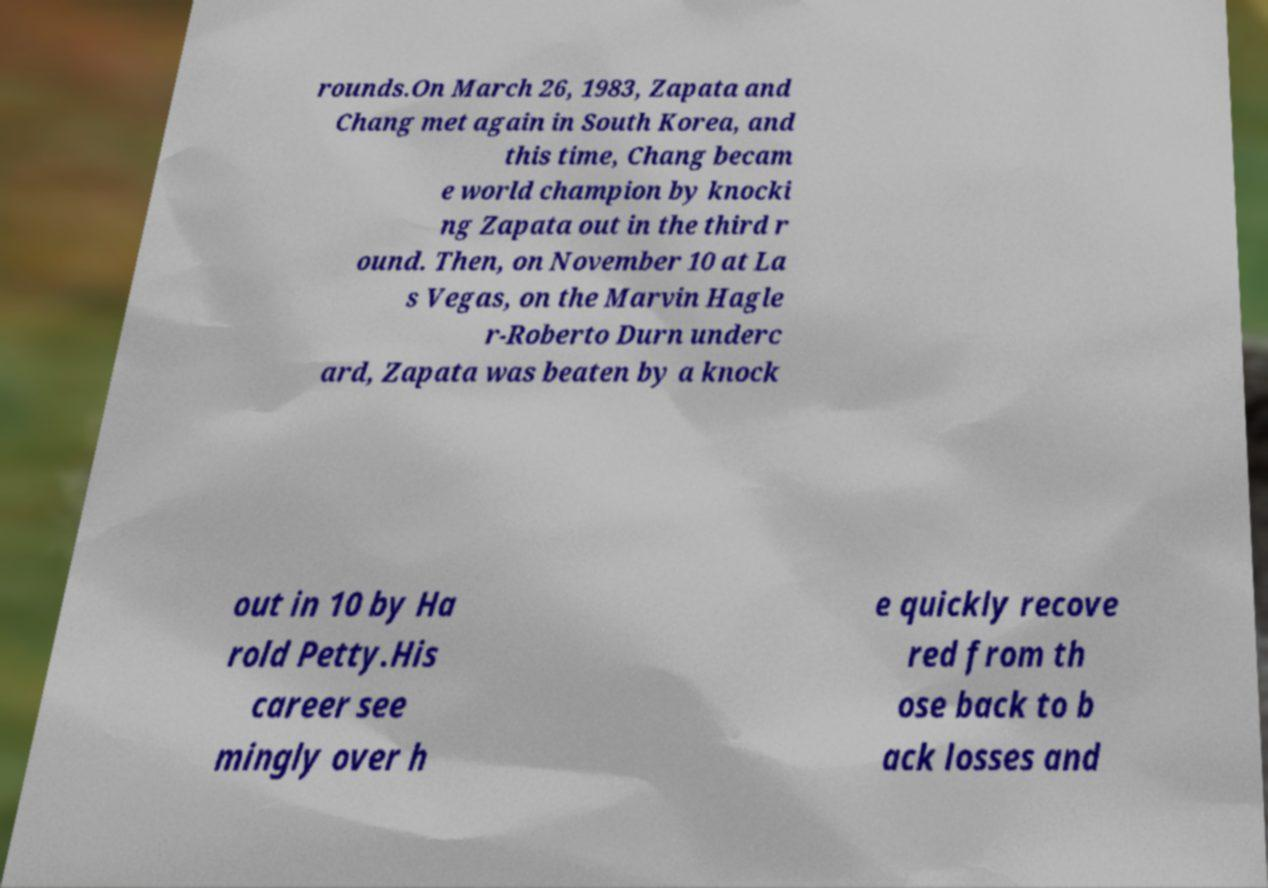Please read and relay the text visible in this image. What does it say? rounds.On March 26, 1983, Zapata and Chang met again in South Korea, and this time, Chang becam e world champion by knocki ng Zapata out in the third r ound. Then, on November 10 at La s Vegas, on the Marvin Hagle r-Roberto Durn underc ard, Zapata was beaten by a knock out in 10 by Ha rold Petty.His career see mingly over h e quickly recove red from th ose back to b ack losses and 